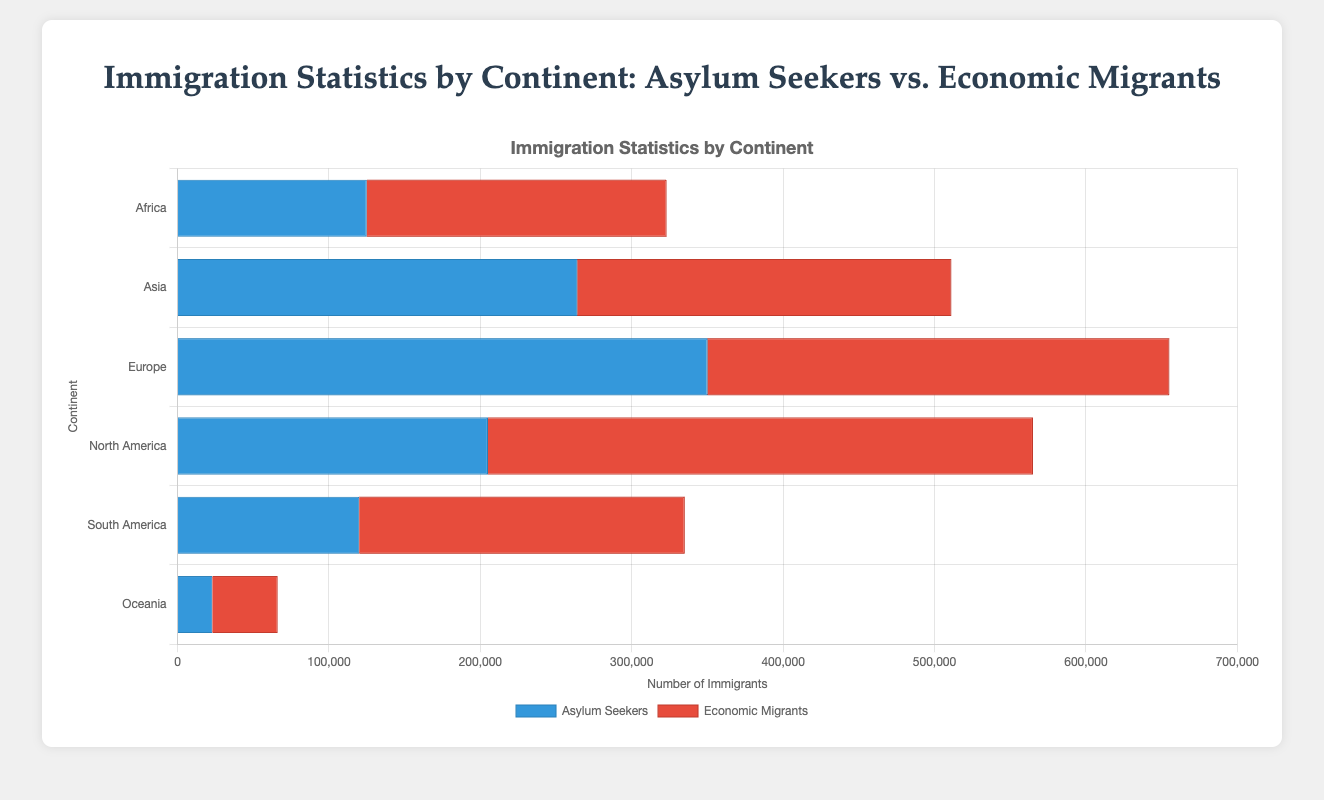Which continent has the highest number of asylum seekers? The continent with the highest number of asylum seekers is represented by the continent whose blue bar is the longest compared to others. The longest blue bar belongs to Europe.
Answer: Europe Which continent has more economic migrants than asylum seekers? By comparing the lengths of the red and blue bars for each continent, we can see that Asia, Europe, North America, South America, and Oceania have longer red bars than blue bars, representing more economic migrants than asylum seekers.
Answer: Asia, Europe, North America, South America, Oceania What is the total number of immigrants (asylum seekers and economic migrants) from Africa? Sum the total number of asylum seekers and economic migrants for Africa. Asylum seekers: 50,000 + 12,000 + 30,000 + 25,000 + 8,000 = 125,000. Economic migrants: 75,000 + 18,000 + 35,000 + 20,000 + 50,000 = 198,000. Total: 125,000 + 198,000 = 323,000.
Answer: 323,000 How much higher is the number of economic migrants compared to asylum seekers in North America? Subtract the total number of asylum seekers from the total number of economic migrants in North America. Economic migrants: 200,000 + 45,000 + 80,000 + 20,000 + 15,000 = 360,000. Asylum seekers: 110,000 + 20,000 + 50,000 + 15,000 + 10,000 = 205,000. Difference: 360,000 - 205,000 = 155,000.
Answer: 155,000 Which continent has the smallest number of total immigrants, and what is that number? Calculate the total number of immigrants for each continent and compare. Africa (323,000), Asia (462,000), Europe (455,000), North America (565,000), South America (415,000), Oceania (63,700). The continent with the smallest number is Oceania.
Answer: Oceania, 63,700 In which continent does the country with the highest number of asylum seekers belong, and what is that number? The country with the highest number of asylum seekers in the provided data is Germany with 120,000 asylum seekers, and it is in Europe.
Answer: Europe, 120,000 What are the average numbers of asylum seekers and economic migrants per country in South America? Calculate the average by summing the numbers for asylum seekers and economic migrants and dividing by the number of countries (5). Asylum seekers: (25,000 + 15,000 + 10,000 + 20,000 + 50,000) / 5 = 120,000 / 5 = 24,000. Economic migrants: (45,000 + 30,000 + 25,000 + 35,000 + 80,000) / 5 = 215,000 / 5 = 43,000.
Answer: 24,000 and 43,000 